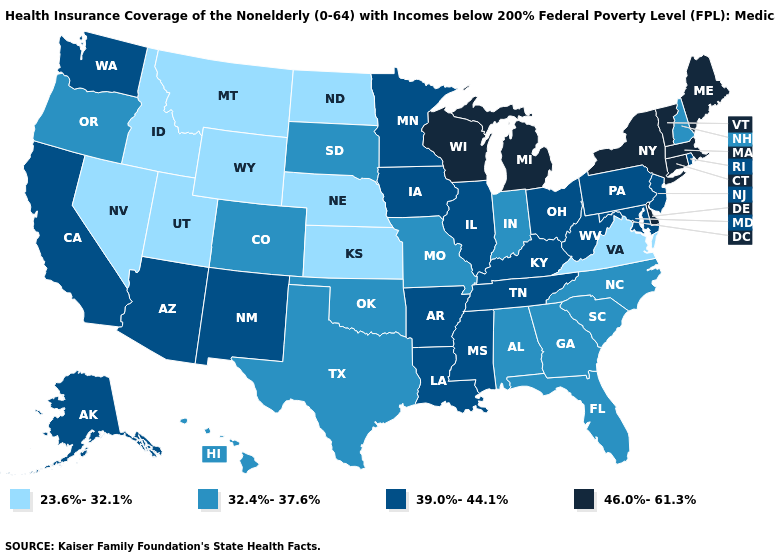Which states have the highest value in the USA?
Answer briefly. Connecticut, Delaware, Maine, Massachusetts, Michigan, New York, Vermont, Wisconsin. Does New Jersey have a lower value than Utah?
Write a very short answer. No. What is the value of Washington?
Write a very short answer. 39.0%-44.1%. Is the legend a continuous bar?
Short answer required. No. Which states have the lowest value in the USA?
Write a very short answer. Idaho, Kansas, Montana, Nebraska, Nevada, North Dakota, Utah, Virginia, Wyoming. Among the states that border West Virginia , which have the lowest value?
Write a very short answer. Virginia. What is the value of New Hampshire?
Write a very short answer. 32.4%-37.6%. Name the states that have a value in the range 46.0%-61.3%?
Answer briefly. Connecticut, Delaware, Maine, Massachusetts, Michigan, New York, Vermont, Wisconsin. What is the value of Illinois?
Answer briefly. 39.0%-44.1%. Does the first symbol in the legend represent the smallest category?
Be succinct. Yes. What is the highest value in the West ?
Be succinct. 39.0%-44.1%. Does North Dakota have a lower value than Nevada?
Be succinct. No. Is the legend a continuous bar?
Answer briefly. No. Name the states that have a value in the range 46.0%-61.3%?
Short answer required. Connecticut, Delaware, Maine, Massachusetts, Michigan, New York, Vermont, Wisconsin. Name the states that have a value in the range 39.0%-44.1%?
Concise answer only. Alaska, Arizona, Arkansas, California, Illinois, Iowa, Kentucky, Louisiana, Maryland, Minnesota, Mississippi, New Jersey, New Mexico, Ohio, Pennsylvania, Rhode Island, Tennessee, Washington, West Virginia. 